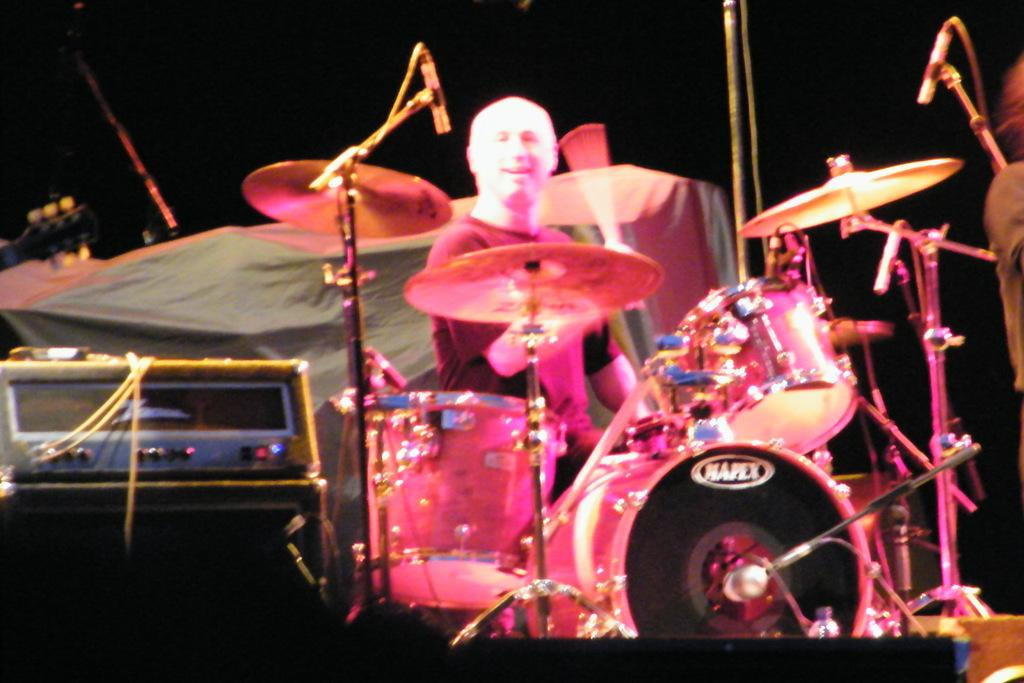What is the man in the image doing? The man is playing drums in the image. What is the color of the box in the image? The box in the image is black. What type of device can be seen in the image? There is an electronic device in the image. Can you describe the object in the background of the image? Unfortunately, the facts provided do not give enough information to describe the object in the background. What type of machine is causing the earthquake in the image? There is no machine or earthquake present in the image. 